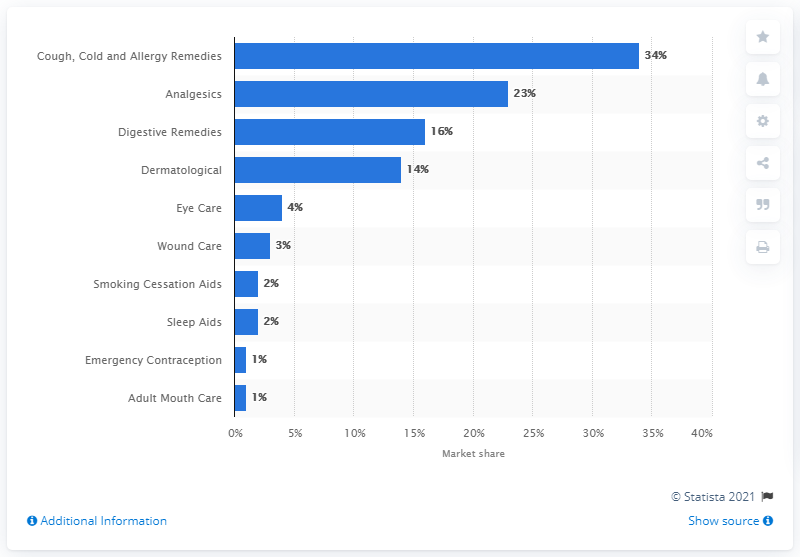Indicate a few pertinent items in this graphic. In 2016, the global market for over-the-counter (OTC) drugs for pain relief, known as analgesics, accounted for approximately 23% of the overall OTC drugs market. 